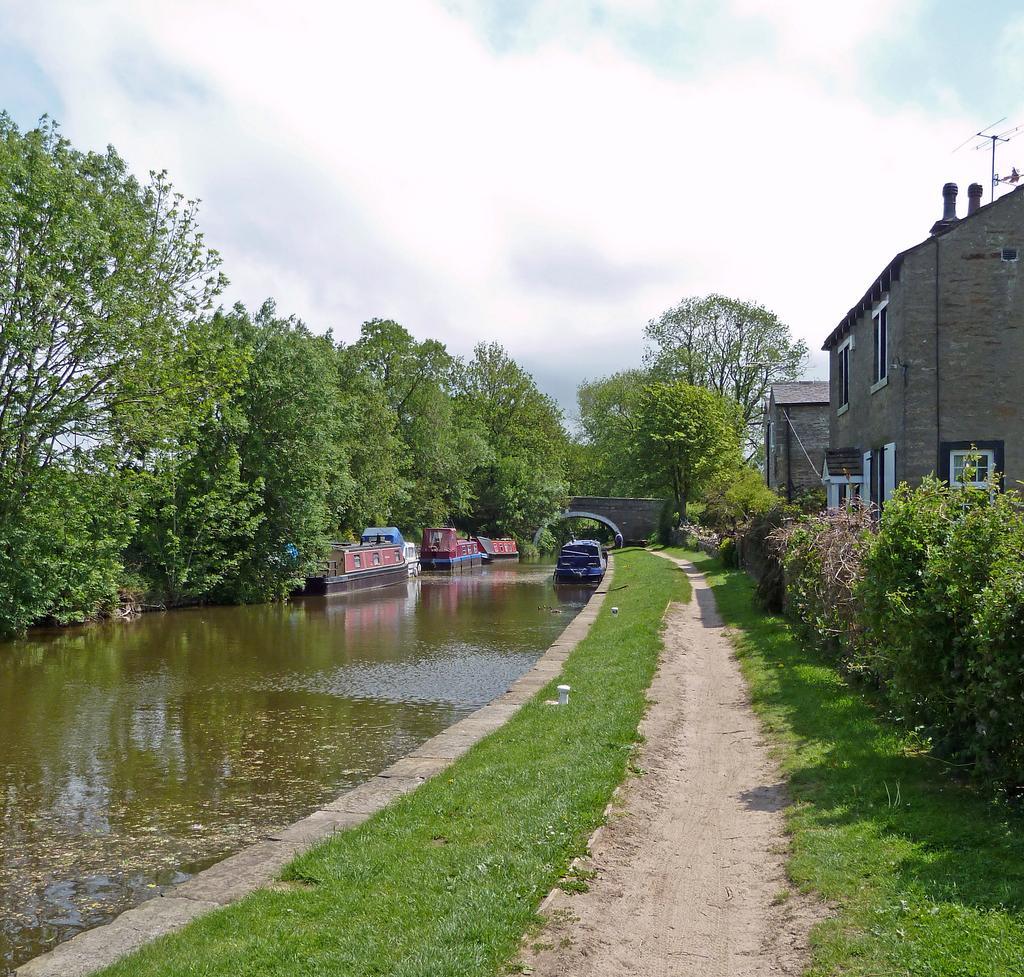Could you give a brief overview of what you see in this image? In this image there is grass on the ground. In the center there is a path. Beside it there are plants. Behind the plants there are buildings. To the left there is the water. There are boats on the water. Behind the boats there are trees. At the top there is the sky. 